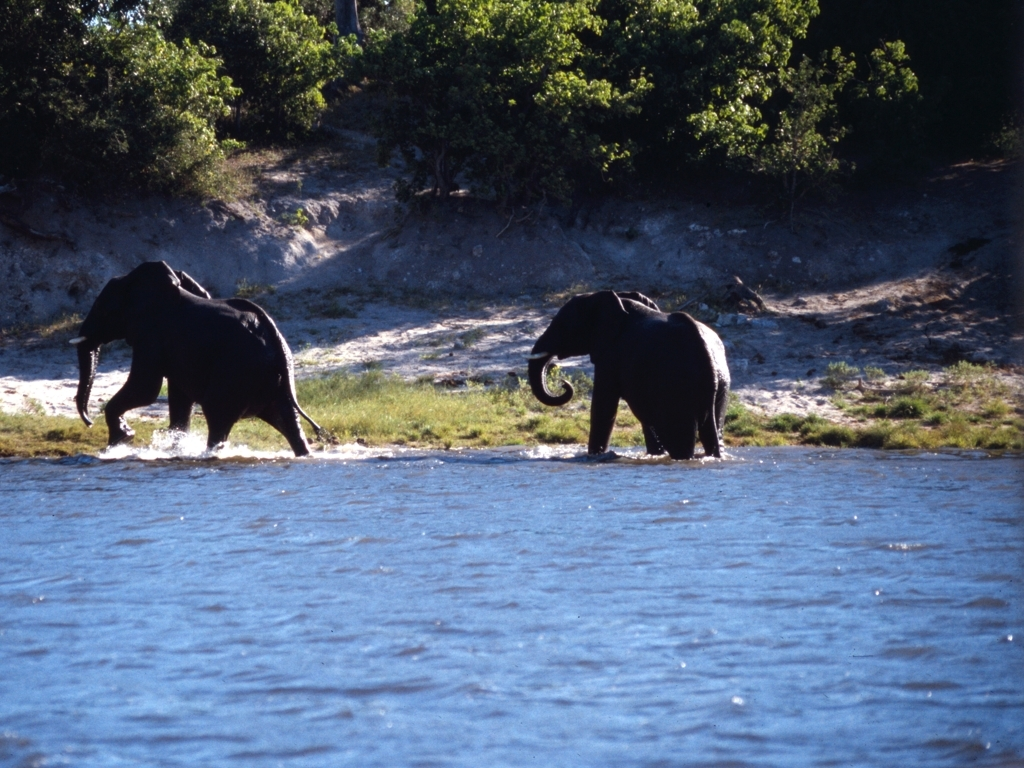Are the two ends of the subject backlit? Yes, the two ends of the elephants are backlit, which is indicated by the glow around their outlines and the contrast between their dark figures and the bright background. 